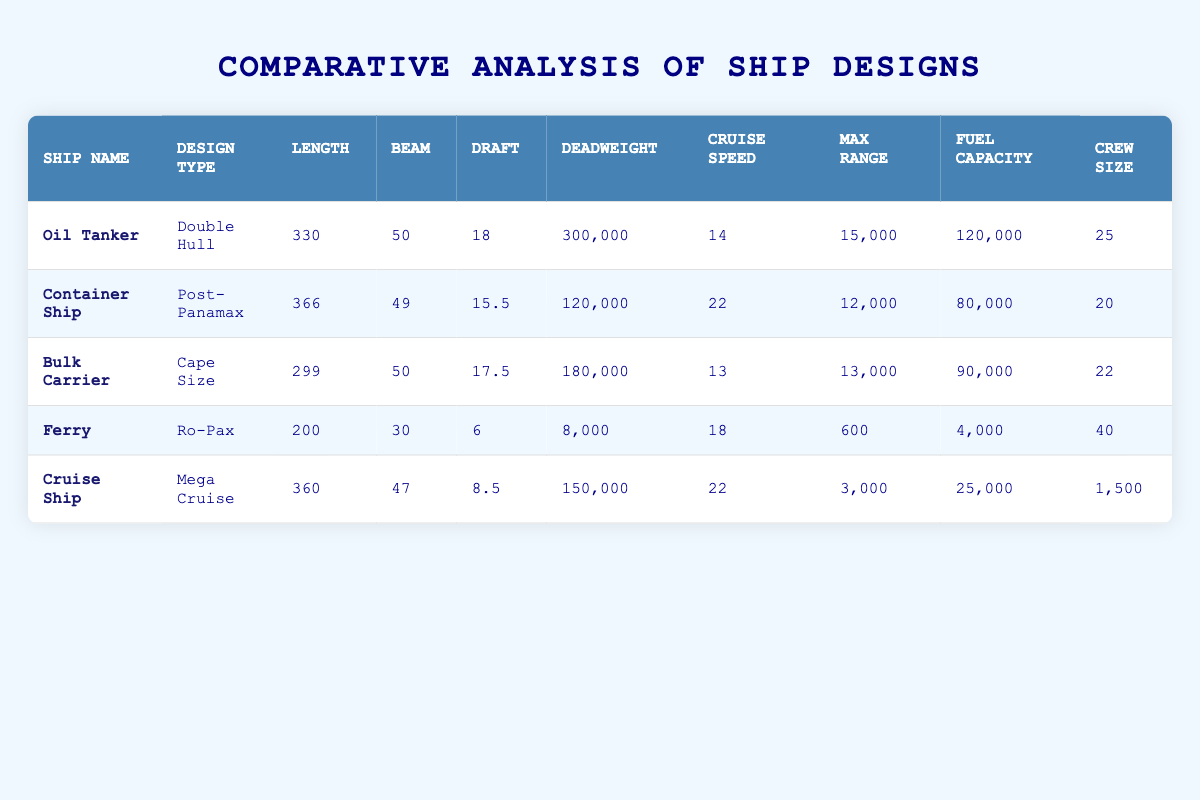What is the maximum range of the Oil Tanker? The maximum range of the Oil Tanker is listed in the table under the "Max Range" column, which is 15,000 nautical miles.
Answer: 15,000 nautical miles Which ship has the largest crew size? By comparing the values in the "Crew Size" column, the Cruise Ship has the largest crew size of 1,500.
Answer: 1,500 What is the combined deadweight of the Bulk Carrier and the Ferry? The deadweight of the Bulk Carrier is 180,000 tons, and the Ferry is 8,000 tons. Adding these two values gives us 180,000 + 8,000 = 188,000 tons.
Answer: 188,000 tons Is the draft of the Container Ship greater than that of the Cruise Ship? The Container Ship has a draft of 15.5 meters, while the Cruise Ship has a draft of 8.5 meters. Because 15.5 is greater than 8.5, the statement is true.
Answer: Yes What is the average cruise speed of all ships listed? To find the average, we sum the cruise speeds: 14 + 22 + 13 + 18 + 22 = 89 knots. Then, we divide by the number of ships (5) to get the average: 89 / 5 = 17.8 knots.
Answer: 17.8 knots How much more fuel capacity does the Oil Tanker have compared to the Ferry? The fuel capacity of the Oil Tanker is 120,000 cubic meters, and the Ferry's fuel capacity is 4,000 cubic meters. The difference is 120,000 - 4,000 = 116,000 cubic meters.
Answer: 116,000 cubic meters Which ship type has the smallest draft and what is that measurement? The Ferry has the smallest draft among the listed ships at 6 meters, as comparing the draft values for all ships shows that 6 is less than 6, 15.5, 17.5, and 18 meters.
Answer: Ferry, 6 meters How many ships have a cruise speed of 22 knots? Looking at the "Cruise Speed" column, both the Container Ship and the Cruise Ship have a cruise speed of 22 knots. Thus, there are two ships with this speed.
Answer: 2 What is the ratio of the deadweight of the Oil Tanker to that of the Bulk Carrier? The deadweight of the Oil Tanker is 300,000 tons and for the Bulk Carrier, it is 180,000 tons. The ratio is 300,000:180,000, which simplifies to 5:3.
Answer: 5:3 